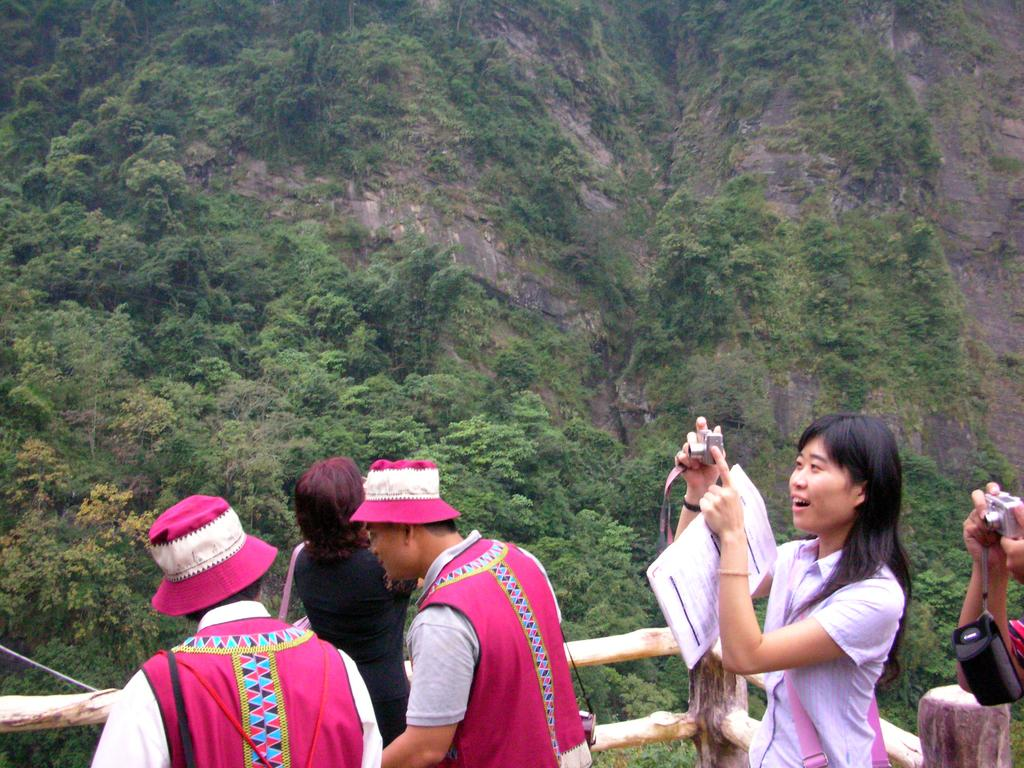What are the people in the image holding? The people in the image are holding cameras. What type of barrier can be seen in the image? There is a wooden fence in the image. What can be seen in the background of the image? Trees and rocks are visible in the background of the image. What type of whip is being used to control the bun in the image? There is no whip or bun present in the image. What territory is being claimed by the people in the image? The image does not depict any territorial claims or disputes. 